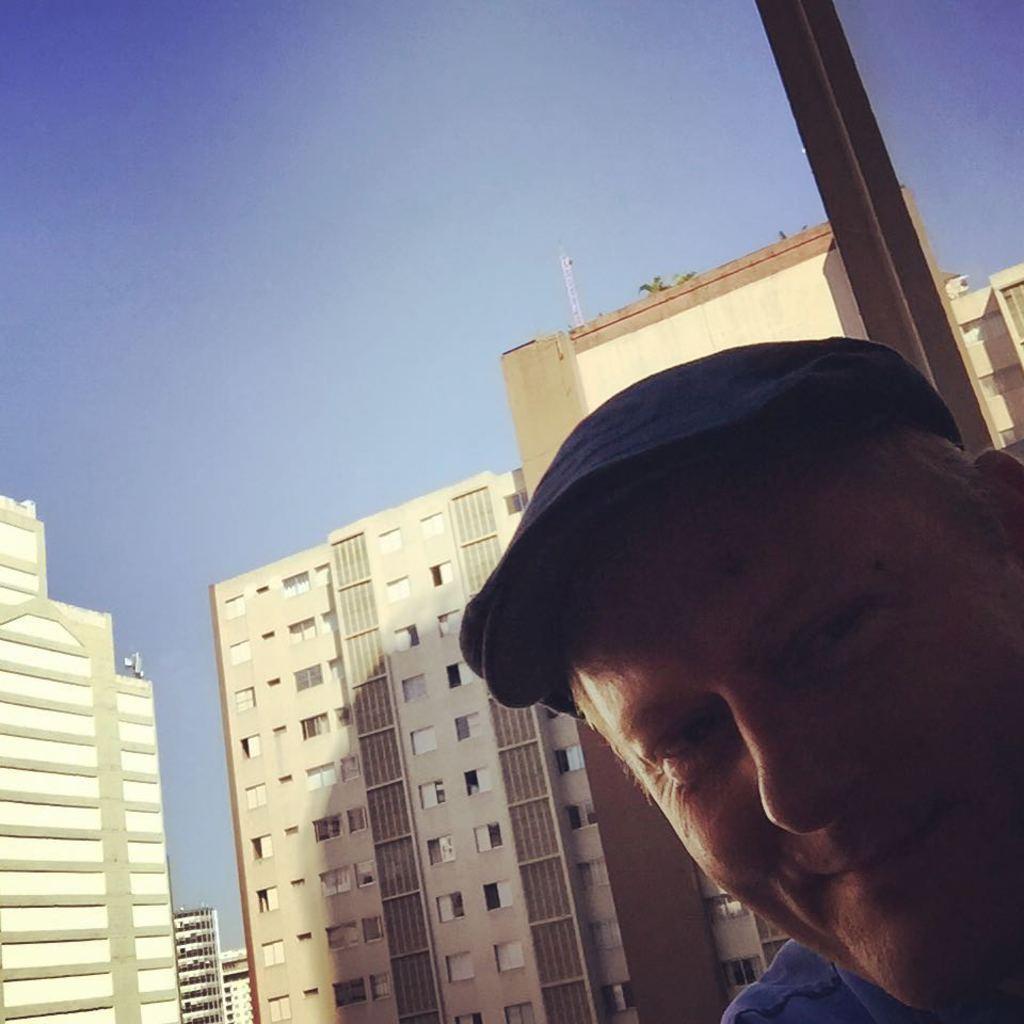How would you summarize this image in a sentence or two? In this image there is a face of a man. He is smiling. He is wearing a cap. Behind him there is a glass window. On the other side of the window there are buildings. At the top there is the sky. 